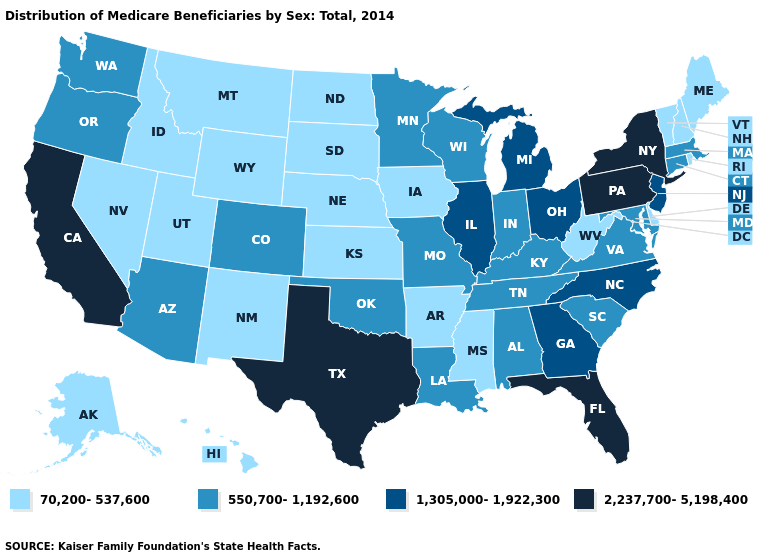What is the highest value in the USA?
Be succinct. 2,237,700-5,198,400. Does Vermont have the lowest value in the USA?
Be succinct. Yes. What is the value of Kansas?
Write a very short answer. 70,200-537,600. Name the states that have a value in the range 2,237,700-5,198,400?
Quick response, please. California, Florida, New York, Pennsylvania, Texas. What is the lowest value in states that border Texas?
Quick response, please. 70,200-537,600. What is the value of Iowa?
Be succinct. 70,200-537,600. What is the lowest value in the USA?
Concise answer only. 70,200-537,600. What is the highest value in the MidWest ?
Concise answer only. 1,305,000-1,922,300. Among the states that border Rhode Island , which have the lowest value?
Quick response, please. Connecticut, Massachusetts. How many symbols are there in the legend?
Answer briefly. 4. What is the value of Louisiana?
Quick response, please. 550,700-1,192,600. Does Connecticut have the highest value in the Northeast?
Quick response, please. No. Name the states that have a value in the range 2,237,700-5,198,400?
Answer briefly. California, Florida, New York, Pennsylvania, Texas. What is the value of Louisiana?
Concise answer only. 550,700-1,192,600. Does the map have missing data?
Write a very short answer. No. 